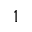Convert formula to latex. <formula><loc_0><loc_0><loc_500><loc_500>^ { 1 }</formula> 